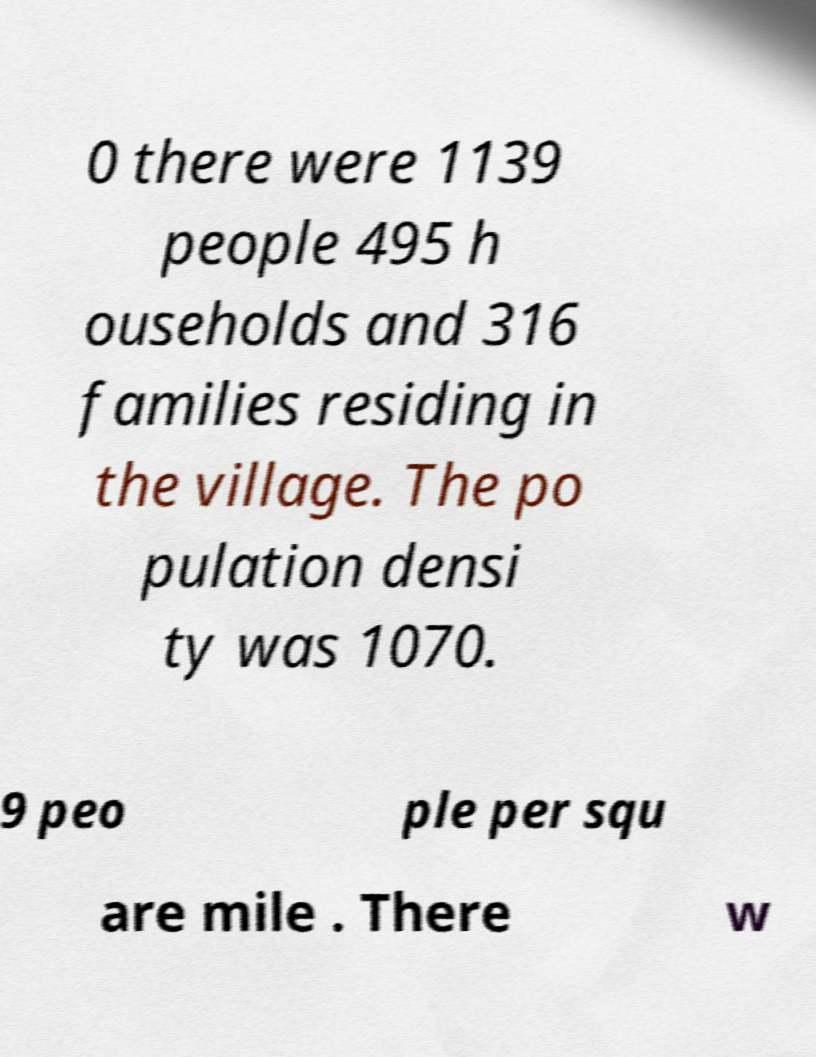What messages or text are displayed in this image? I need them in a readable, typed format. 0 there were 1139 people 495 h ouseholds and 316 families residing in the village. The po pulation densi ty was 1070. 9 peo ple per squ are mile . There w 